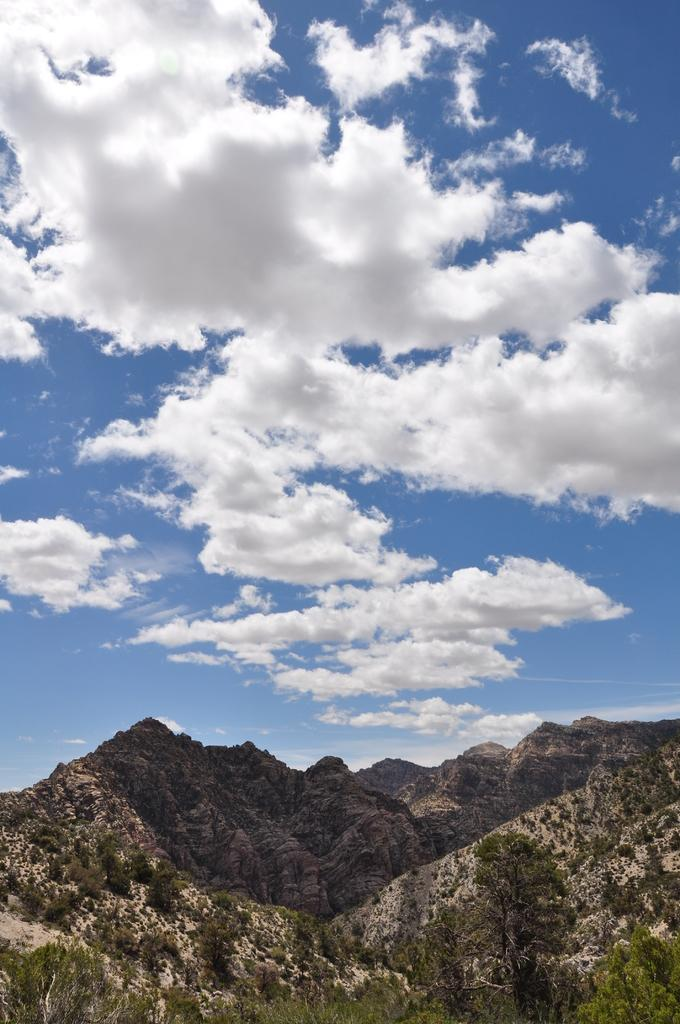What type of landscape is depicted at the bottom of the image? There are mountains at the bottom of the image. What is visible at the top of the image? The sky is visible at the top of the image. What can be seen in the sky? Clouds are present in the sky. Can you tell me how many nerves are visible in the image? There are no nerves present in the image; it features mountains and clouds in the sky. What type of wing is shown in the image? There is no wing present in the image; it features mountains and clouds in the sky. 